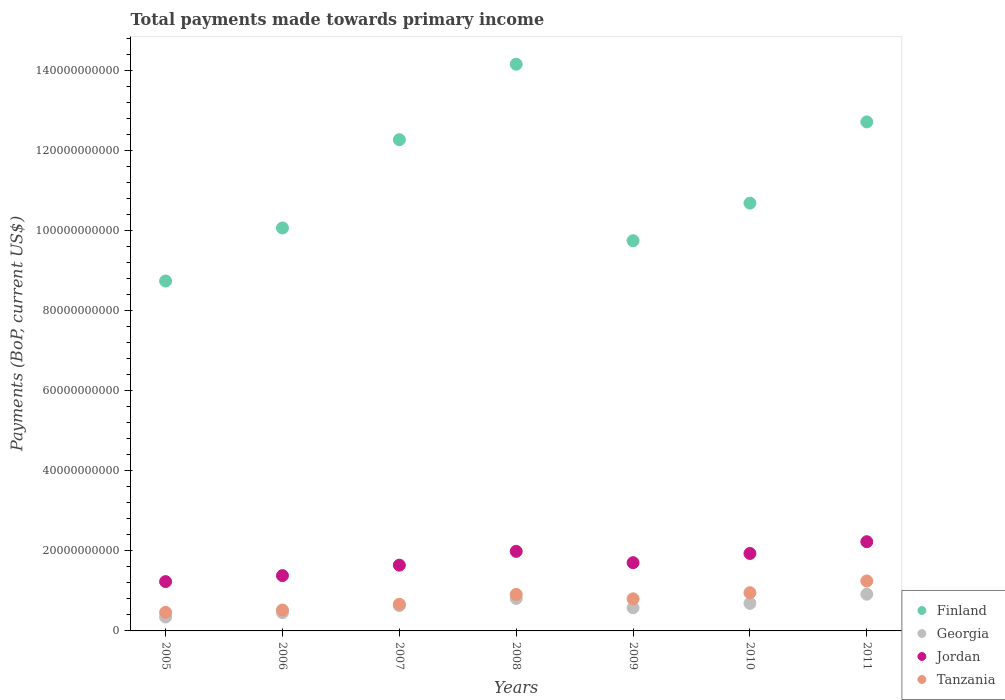Is the number of dotlines equal to the number of legend labels?
Your response must be concise. Yes. What is the total payments made towards primary income in Tanzania in 2008?
Provide a short and direct response. 9.11e+09. Across all years, what is the maximum total payments made towards primary income in Finland?
Provide a short and direct response. 1.42e+11. Across all years, what is the minimum total payments made towards primary income in Tanzania?
Your answer should be compact. 4.64e+09. In which year was the total payments made towards primary income in Georgia maximum?
Provide a short and direct response. 2011. In which year was the total payments made towards primary income in Finland minimum?
Ensure brevity in your answer.  2005. What is the total total payments made towards primary income in Jordan in the graph?
Keep it short and to the point. 1.21e+11. What is the difference between the total payments made towards primary income in Jordan in 2009 and that in 2011?
Ensure brevity in your answer.  -5.23e+09. What is the difference between the total payments made towards primary income in Tanzania in 2006 and the total payments made towards primary income in Finland in 2009?
Offer a terse response. -9.22e+1. What is the average total payments made towards primary income in Jordan per year?
Your response must be concise. 1.73e+1. In the year 2005, what is the difference between the total payments made towards primary income in Finland and total payments made towards primary income in Jordan?
Your answer should be compact. 7.51e+1. In how many years, is the total payments made towards primary income in Jordan greater than 96000000000 US$?
Your answer should be compact. 0. What is the ratio of the total payments made towards primary income in Finland in 2006 to that in 2009?
Offer a very short reply. 1.03. Is the difference between the total payments made towards primary income in Finland in 2005 and 2010 greater than the difference between the total payments made towards primary income in Jordan in 2005 and 2010?
Give a very brief answer. No. What is the difference between the highest and the second highest total payments made towards primary income in Jordan?
Your response must be concise. 2.41e+09. What is the difference between the highest and the lowest total payments made towards primary income in Jordan?
Offer a terse response. 9.96e+09. In how many years, is the total payments made towards primary income in Finland greater than the average total payments made towards primary income in Finland taken over all years?
Make the answer very short. 3. Is the sum of the total payments made towards primary income in Tanzania in 2008 and 2010 greater than the maximum total payments made towards primary income in Georgia across all years?
Make the answer very short. Yes. Is it the case that in every year, the sum of the total payments made towards primary income in Tanzania and total payments made towards primary income in Finland  is greater than the sum of total payments made towards primary income in Georgia and total payments made towards primary income in Jordan?
Your answer should be very brief. Yes. Is it the case that in every year, the sum of the total payments made towards primary income in Georgia and total payments made towards primary income in Tanzania  is greater than the total payments made towards primary income in Jordan?
Your answer should be compact. No. How many dotlines are there?
Ensure brevity in your answer.  4. What is the difference between two consecutive major ticks on the Y-axis?
Your response must be concise. 2.00e+1. Are the values on the major ticks of Y-axis written in scientific E-notation?
Provide a short and direct response. No. Does the graph contain grids?
Keep it short and to the point. No. Where does the legend appear in the graph?
Your response must be concise. Bottom right. What is the title of the graph?
Ensure brevity in your answer.  Total payments made towards primary income. Does "Costa Rica" appear as one of the legend labels in the graph?
Keep it short and to the point. No. What is the label or title of the Y-axis?
Give a very brief answer. Payments (BoP, current US$). What is the Payments (BoP, current US$) of Finland in 2005?
Your response must be concise. 8.74e+1. What is the Payments (BoP, current US$) in Georgia in 2005?
Give a very brief answer. 3.47e+09. What is the Payments (BoP, current US$) of Jordan in 2005?
Ensure brevity in your answer.  1.23e+1. What is the Payments (BoP, current US$) of Tanzania in 2005?
Give a very brief answer. 4.64e+09. What is the Payments (BoP, current US$) of Finland in 2006?
Your answer should be very brief. 1.01e+11. What is the Payments (BoP, current US$) in Georgia in 2006?
Provide a succinct answer. 4.56e+09. What is the Payments (BoP, current US$) in Jordan in 2006?
Provide a succinct answer. 1.38e+1. What is the Payments (BoP, current US$) in Tanzania in 2006?
Offer a terse response. 5.22e+09. What is the Payments (BoP, current US$) in Finland in 2007?
Provide a succinct answer. 1.23e+11. What is the Payments (BoP, current US$) in Georgia in 2007?
Your answer should be very brief. 6.32e+09. What is the Payments (BoP, current US$) in Jordan in 2007?
Make the answer very short. 1.64e+1. What is the Payments (BoP, current US$) in Tanzania in 2007?
Make the answer very short. 6.66e+09. What is the Payments (BoP, current US$) of Finland in 2008?
Your answer should be very brief. 1.42e+11. What is the Payments (BoP, current US$) of Georgia in 2008?
Offer a terse response. 8.11e+09. What is the Payments (BoP, current US$) of Jordan in 2008?
Keep it short and to the point. 1.99e+1. What is the Payments (BoP, current US$) in Tanzania in 2008?
Your response must be concise. 9.11e+09. What is the Payments (BoP, current US$) of Finland in 2009?
Offer a very short reply. 9.74e+1. What is the Payments (BoP, current US$) of Georgia in 2009?
Offer a terse response. 5.78e+09. What is the Payments (BoP, current US$) in Jordan in 2009?
Ensure brevity in your answer.  1.70e+1. What is the Payments (BoP, current US$) in Tanzania in 2009?
Provide a succinct answer. 8.02e+09. What is the Payments (BoP, current US$) in Finland in 2010?
Give a very brief answer. 1.07e+11. What is the Payments (BoP, current US$) of Georgia in 2010?
Make the answer very short. 6.89e+09. What is the Payments (BoP, current US$) in Jordan in 2010?
Keep it short and to the point. 1.93e+1. What is the Payments (BoP, current US$) of Tanzania in 2010?
Offer a very short reply. 9.54e+09. What is the Payments (BoP, current US$) of Finland in 2011?
Provide a succinct answer. 1.27e+11. What is the Payments (BoP, current US$) of Georgia in 2011?
Keep it short and to the point. 9.17e+09. What is the Payments (BoP, current US$) in Jordan in 2011?
Keep it short and to the point. 2.23e+1. What is the Payments (BoP, current US$) of Tanzania in 2011?
Keep it short and to the point. 1.25e+1. Across all years, what is the maximum Payments (BoP, current US$) of Finland?
Make the answer very short. 1.42e+11. Across all years, what is the maximum Payments (BoP, current US$) of Georgia?
Give a very brief answer. 9.17e+09. Across all years, what is the maximum Payments (BoP, current US$) in Jordan?
Give a very brief answer. 2.23e+1. Across all years, what is the maximum Payments (BoP, current US$) of Tanzania?
Offer a terse response. 1.25e+1. Across all years, what is the minimum Payments (BoP, current US$) in Finland?
Provide a short and direct response. 8.74e+1. Across all years, what is the minimum Payments (BoP, current US$) in Georgia?
Your answer should be very brief. 3.47e+09. Across all years, what is the minimum Payments (BoP, current US$) in Jordan?
Give a very brief answer. 1.23e+1. Across all years, what is the minimum Payments (BoP, current US$) of Tanzania?
Offer a very short reply. 4.64e+09. What is the total Payments (BoP, current US$) in Finland in the graph?
Keep it short and to the point. 7.84e+11. What is the total Payments (BoP, current US$) in Georgia in the graph?
Keep it short and to the point. 4.43e+1. What is the total Payments (BoP, current US$) of Jordan in the graph?
Make the answer very short. 1.21e+11. What is the total Payments (BoP, current US$) in Tanzania in the graph?
Give a very brief answer. 5.57e+1. What is the difference between the Payments (BoP, current US$) in Finland in 2005 and that in 2006?
Keep it short and to the point. -1.32e+1. What is the difference between the Payments (BoP, current US$) of Georgia in 2005 and that in 2006?
Your response must be concise. -1.09e+09. What is the difference between the Payments (BoP, current US$) of Jordan in 2005 and that in 2006?
Your answer should be compact. -1.50e+09. What is the difference between the Payments (BoP, current US$) of Tanzania in 2005 and that in 2006?
Provide a succinct answer. -5.76e+08. What is the difference between the Payments (BoP, current US$) in Finland in 2005 and that in 2007?
Your answer should be very brief. -3.53e+1. What is the difference between the Payments (BoP, current US$) in Georgia in 2005 and that in 2007?
Offer a very short reply. -2.86e+09. What is the difference between the Payments (BoP, current US$) of Jordan in 2005 and that in 2007?
Keep it short and to the point. -4.11e+09. What is the difference between the Payments (BoP, current US$) in Tanzania in 2005 and that in 2007?
Offer a terse response. -2.02e+09. What is the difference between the Payments (BoP, current US$) of Finland in 2005 and that in 2008?
Keep it short and to the point. -5.41e+1. What is the difference between the Payments (BoP, current US$) of Georgia in 2005 and that in 2008?
Give a very brief answer. -4.65e+09. What is the difference between the Payments (BoP, current US$) in Jordan in 2005 and that in 2008?
Ensure brevity in your answer.  -7.55e+09. What is the difference between the Payments (BoP, current US$) of Tanzania in 2005 and that in 2008?
Offer a very short reply. -4.47e+09. What is the difference between the Payments (BoP, current US$) in Finland in 2005 and that in 2009?
Your answer should be very brief. -1.01e+1. What is the difference between the Payments (BoP, current US$) of Georgia in 2005 and that in 2009?
Your answer should be very brief. -2.31e+09. What is the difference between the Payments (BoP, current US$) in Jordan in 2005 and that in 2009?
Offer a terse response. -4.73e+09. What is the difference between the Payments (BoP, current US$) of Tanzania in 2005 and that in 2009?
Ensure brevity in your answer.  -3.37e+09. What is the difference between the Payments (BoP, current US$) in Finland in 2005 and that in 2010?
Provide a short and direct response. -1.94e+1. What is the difference between the Payments (BoP, current US$) of Georgia in 2005 and that in 2010?
Provide a short and direct response. -3.42e+09. What is the difference between the Payments (BoP, current US$) in Jordan in 2005 and that in 2010?
Provide a succinct answer. -7.03e+09. What is the difference between the Payments (BoP, current US$) in Tanzania in 2005 and that in 2010?
Your response must be concise. -4.90e+09. What is the difference between the Payments (BoP, current US$) of Finland in 2005 and that in 2011?
Make the answer very short. -3.97e+1. What is the difference between the Payments (BoP, current US$) in Georgia in 2005 and that in 2011?
Make the answer very short. -5.70e+09. What is the difference between the Payments (BoP, current US$) of Jordan in 2005 and that in 2011?
Provide a succinct answer. -9.96e+09. What is the difference between the Payments (BoP, current US$) of Tanzania in 2005 and that in 2011?
Your answer should be very brief. -7.84e+09. What is the difference between the Payments (BoP, current US$) of Finland in 2006 and that in 2007?
Your response must be concise. -2.20e+1. What is the difference between the Payments (BoP, current US$) in Georgia in 2006 and that in 2007?
Provide a succinct answer. -1.77e+09. What is the difference between the Payments (BoP, current US$) of Jordan in 2006 and that in 2007?
Offer a terse response. -2.61e+09. What is the difference between the Payments (BoP, current US$) of Tanzania in 2006 and that in 2007?
Provide a succinct answer. -1.45e+09. What is the difference between the Payments (BoP, current US$) in Finland in 2006 and that in 2008?
Offer a terse response. -4.09e+1. What is the difference between the Payments (BoP, current US$) in Georgia in 2006 and that in 2008?
Give a very brief answer. -3.56e+09. What is the difference between the Payments (BoP, current US$) of Jordan in 2006 and that in 2008?
Provide a short and direct response. -6.06e+09. What is the difference between the Payments (BoP, current US$) of Tanzania in 2006 and that in 2008?
Ensure brevity in your answer.  -3.89e+09. What is the difference between the Payments (BoP, current US$) in Finland in 2006 and that in 2009?
Make the answer very short. 3.19e+09. What is the difference between the Payments (BoP, current US$) of Georgia in 2006 and that in 2009?
Your response must be concise. -1.22e+09. What is the difference between the Payments (BoP, current US$) in Jordan in 2006 and that in 2009?
Give a very brief answer. -3.23e+09. What is the difference between the Payments (BoP, current US$) of Tanzania in 2006 and that in 2009?
Provide a short and direct response. -2.80e+09. What is the difference between the Payments (BoP, current US$) in Finland in 2006 and that in 2010?
Your response must be concise. -6.19e+09. What is the difference between the Payments (BoP, current US$) in Georgia in 2006 and that in 2010?
Offer a very short reply. -2.33e+09. What is the difference between the Payments (BoP, current US$) of Jordan in 2006 and that in 2010?
Offer a very short reply. -5.53e+09. What is the difference between the Payments (BoP, current US$) in Tanzania in 2006 and that in 2010?
Your answer should be compact. -4.32e+09. What is the difference between the Payments (BoP, current US$) of Finland in 2006 and that in 2011?
Offer a terse response. -2.65e+1. What is the difference between the Payments (BoP, current US$) in Georgia in 2006 and that in 2011?
Keep it short and to the point. -4.61e+09. What is the difference between the Payments (BoP, current US$) of Jordan in 2006 and that in 2011?
Ensure brevity in your answer.  -8.47e+09. What is the difference between the Payments (BoP, current US$) in Tanzania in 2006 and that in 2011?
Ensure brevity in your answer.  -7.26e+09. What is the difference between the Payments (BoP, current US$) in Finland in 2007 and that in 2008?
Your answer should be very brief. -1.89e+1. What is the difference between the Payments (BoP, current US$) of Georgia in 2007 and that in 2008?
Offer a very short reply. -1.79e+09. What is the difference between the Payments (BoP, current US$) in Jordan in 2007 and that in 2008?
Provide a succinct answer. -3.45e+09. What is the difference between the Payments (BoP, current US$) in Tanzania in 2007 and that in 2008?
Ensure brevity in your answer.  -2.45e+09. What is the difference between the Payments (BoP, current US$) of Finland in 2007 and that in 2009?
Your answer should be compact. 2.52e+1. What is the difference between the Payments (BoP, current US$) in Georgia in 2007 and that in 2009?
Ensure brevity in your answer.  5.46e+08. What is the difference between the Payments (BoP, current US$) of Jordan in 2007 and that in 2009?
Ensure brevity in your answer.  -6.23e+08. What is the difference between the Payments (BoP, current US$) in Tanzania in 2007 and that in 2009?
Give a very brief answer. -1.35e+09. What is the difference between the Payments (BoP, current US$) in Finland in 2007 and that in 2010?
Your response must be concise. 1.58e+1. What is the difference between the Payments (BoP, current US$) of Georgia in 2007 and that in 2010?
Your answer should be very brief. -5.60e+08. What is the difference between the Payments (BoP, current US$) of Jordan in 2007 and that in 2010?
Keep it short and to the point. -2.92e+09. What is the difference between the Payments (BoP, current US$) of Tanzania in 2007 and that in 2010?
Make the answer very short. -2.88e+09. What is the difference between the Payments (BoP, current US$) of Finland in 2007 and that in 2011?
Keep it short and to the point. -4.45e+09. What is the difference between the Payments (BoP, current US$) in Georgia in 2007 and that in 2011?
Provide a succinct answer. -2.84e+09. What is the difference between the Payments (BoP, current US$) in Jordan in 2007 and that in 2011?
Offer a very short reply. -5.86e+09. What is the difference between the Payments (BoP, current US$) in Tanzania in 2007 and that in 2011?
Ensure brevity in your answer.  -5.81e+09. What is the difference between the Payments (BoP, current US$) of Finland in 2008 and that in 2009?
Keep it short and to the point. 4.41e+1. What is the difference between the Payments (BoP, current US$) in Georgia in 2008 and that in 2009?
Ensure brevity in your answer.  2.34e+09. What is the difference between the Payments (BoP, current US$) of Jordan in 2008 and that in 2009?
Provide a succinct answer. 2.82e+09. What is the difference between the Payments (BoP, current US$) of Tanzania in 2008 and that in 2009?
Your response must be concise. 1.10e+09. What is the difference between the Payments (BoP, current US$) of Finland in 2008 and that in 2010?
Provide a short and direct response. 3.47e+1. What is the difference between the Payments (BoP, current US$) of Georgia in 2008 and that in 2010?
Your answer should be very brief. 1.23e+09. What is the difference between the Payments (BoP, current US$) of Jordan in 2008 and that in 2010?
Offer a terse response. 5.25e+08. What is the difference between the Payments (BoP, current US$) of Tanzania in 2008 and that in 2010?
Your answer should be compact. -4.30e+08. What is the difference between the Payments (BoP, current US$) in Finland in 2008 and that in 2011?
Offer a very short reply. 1.44e+1. What is the difference between the Payments (BoP, current US$) of Georgia in 2008 and that in 2011?
Ensure brevity in your answer.  -1.05e+09. What is the difference between the Payments (BoP, current US$) in Jordan in 2008 and that in 2011?
Make the answer very short. -2.41e+09. What is the difference between the Payments (BoP, current US$) of Tanzania in 2008 and that in 2011?
Offer a terse response. -3.37e+09. What is the difference between the Payments (BoP, current US$) of Finland in 2009 and that in 2010?
Keep it short and to the point. -9.38e+09. What is the difference between the Payments (BoP, current US$) in Georgia in 2009 and that in 2010?
Offer a terse response. -1.11e+09. What is the difference between the Payments (BoP, current US$) of Jordan in 2009 and that in 2010?
Make the answer very short. -2.30e+09. What is the difference between the Payments (BoP, current US$) in Tanzania in 2009 and that in 2010?
Your answer should be very brief. -1.53e+09. What is the difference between the Payments (BoP, current US$) in Finland in 2009 and that in 2011?
Your answer should be very brief. -2.97e+1. What is the difference between the Payments (BoP, current US$) of Georgia in 2009 and that in 2011?
Make the answer very short. -3.39e+09. What is the difference between the Payments (BoP, current US$) in Jordan in 2009 and that in 2011?
Offer a very short reply. -5.23e+09. What is the difference between the Payments (BoP, current US$) in Tanzania in 2009 and that in 2011?
Provide a succinct answer. -4.46e+09. What is the difference between the Payments (BoP, current US$) in Finland in 2010 and that in 2011?
Ensure brevity in your answer.  -2.03e+1. What is the difference between the Payments (BoP, current US$) of Georgia in 2010 and that in 2011?
Keep it short and to the point. -2.28e+09. What is the difference between the Payments (BoP, current US$) of Jordan in 2010 and that in 2011?
Your answer should be compact. -2.93e+09. What is the difference between the Payments (BoP, current US$) of Tanzania in 2010 and that in 2011?
Keep it short and to the point. -2.94e+09. What is the difference between the Payments (BoP, current US$) in Finland in 2005 and the Payments (BoP, current US$) in Georgia in 2006?
Provide a short and direct response. 8.28e+1. What is the difference between the Payments (BoP, current US$) of Finland in 2005 and the Payments (BoP, current US$) of Jordan in 2006?
Provide a succinct answer. 7.36e+1. What is the difference between the Payments (BoP, current US$) of Finland in 2005 and the Payments (BoP, current US$) of Tanzania in 2006?
Make the answer very short. 8.22e+1. What is the difference between the Payments (BoP, current US$) in Georgia in 2005 and the Payments (BoP, current US$) in Jordan in 2006?
Provide a succinct answer. -1.03e+1. What is the difference between the Payments (BoP, current US$) in Georgia in 2005 and the Payments (BoP, current US$) in Tanzania in 2006?
Your answer should be very brief. -1.75e+09. What is the difference between the Payments (BoP, current US$) of Jordan in 2005 and the Payments (BoP, current US$) of Tanzania in 2006?
Offer a very short reply. 7.10e+09. What is the difference between the Payments (BoP, current US$) in Finland in 2005 and the Payments (BoP, current US$) in Georgia in 2007?
Keep it short and to the point. 8.11e+1. What is the difference between the Payments (BoP, current US$) of Finland in 2005 and the Payments (BoP, current US$) of Jordan in 2007?
Provide a short and direct response. 7.10e+1. What is the difference between the Payments (BoP, current US$) in Finland in 2005 and the Payments (BoP, current US$) in Tanzania in 2007?
Your answer should be compact. 8.07e+1. What is the difference between the Payments (BoP, current US$) in Georgia in 2005 and the Payments (BoP, current US$) in Jordan in 2007?
Keep it short and to the point. -1.30e+1. What is the difference between the Payments (BoP, current US$) of Georgia in 2005 and the Payments (BoP, current US$) of Tanzania in 2007?
Keep it short and to the point. -3.19e+09. What is the difference between the Payments (BoP, current US$) in Jordan in 2005 and the Payments (BoP, current US$) in Tanzania in 2007?
Provide a succinct answer. 5.65e+09. What is the difference between the Payments (BoP, current US$) of Finland in 2005 and the Payments (BoP, current US$) of Georgia in 2008?
Provide a short and direct response. 7.93e+1. What is the difference between the Payments (BoP, current US$) of Finland in 2005 and the Payments (BoP, current US$) of Jordan in 2008?
Ensure brevity in your answer.  6.75e+1. What is the difference between the Payments (BoP, current US$) in Finland in 2005 and the Payments (BoP, current US$) in Tanzania in 2008?
Offer a very short reply. 7.83e+1. What is the difference between the Payments (BoP, current US$) in Georgia in 2005 and the Payments (BoP, current US$) in Jordan in 2008?
Offer a very short reply. -1.64e+1. What is the difference between the Payments (BoP, current US$) of Georgia in 2005 and the Payments (BoP, current US$) of Tanzania in 2008?
Your answer should be compact. -5.64e+09. What is the difference between the Payments (BoP, current US$) in Jordan in 2005 and the Payments (BoP, current US$) in Tanzania in 2008?
Make the answer very short. 3.20e+09. What is the difference between the Payments (BoP, current US$) of Finland in 2005 and the Payments (BoP, current US$) of Georgia in 2009?
Keep it short and to the point. 8.16e+1. What is the difference between the Payments (BoP, current US$) in Finland in 2005 and the Payments (BoP, current US$) in Jordan in 2009?
Your answer should be very brief. 7.03e+1. What is the difference between the Payments (BoP, current US$) of Finland in 2005 and the Payments (BoP, current US$) of Tanzania in 2009?
Provide a short and direct response. 7.94e+1. What is the difference between the Payments (BoP, current US$) in Georgia in 2005 and the Payments (BoP, current US$) in Jordan in 2009?
Keep it short and to the point. -1.36e+1. What is the difference between the Payments (BoP, current US$) of Georgia in 2005 and the Payments (BoP, current US$) of Tanzania in 2009?
Provide a short and direct response. -4.55e+09. What is the difference between the Payments (BoP, current US$) of Jordan in 2005 and the Payments (BoP, current US$) of Tanzania in 2009?
Your response must be concise. 4.30e+09. What is the difference between the Payments (BoP, current US$) in Finland in 2005 and the Payments (BoP, current US$) in Georgia in 2010?
Your answer should be very brief. 8.05e+1. What is the difference between the Payments (BoP, current US$) in Finland in 2005 and the Payments (BoP, current US$) in Jordan in 2010?
Keep it short and to the point. 6.80e+1. What is the difference between the Payments (BoP, current US$) in Finland in 2005 and the Payments (BoP, current US$) in Tanzania in 2010?
Your answer should be very brief. 7.78e+1. What is the difference between the Payments (BoP, current US$) of Georgia in 2005 and the Payments (BoP, current US$) of Jordan in 2010?
Your response must be concise. -1.59e+1. What is the difference between the Payments (BoP, current US$) of Georgia in 2005 and the Payments (BoP, current US$) of Tanzania in 2010?
Offer a terse response. -6.07e+09. What is the difference between the Payments (BoP, current US$) of Jordan in 2005 and the Payments (BoP, current US$) of Tanzania in 2010?
Give a very brief answer. 2.77e+09. What is the difference between the Payments (BoP, current US$) of Finland in 2005 and the Payments (BoP, current US$) of Georgia in 2011?
Offer a terse response. 7.82e+1. What is the difference between the Payments (BoP, current US$) of Finland in 2005 and the Payments (BoP, current US$) of Jordan in 2011?
Provide a short and direct response. 6.51e+1. What is the difference between the Payments (BoP, current US$) of Finland in 2005 and the Payments (BoP, current US$) of Tanzania in 2011?
Your answer should be very brief. 7.49e+1. What is the difference between the Payments (BoP, current US$) of Georgia in 2005 and the Payments (BoP, current US$) of Jordan in 2011?
Ensure brevity in your answer.  -1.88e+1. What is the difference between the Payments (BoP, current US$) in Georgia in 2005 and the Payments (BoP, current US$) in Tanzania in 2011?
Make the answer very short. -9.01e+09. What is the difference between the Payments (BoP, current US$) of Jordan in 2005 and the Payments (BoP, current US$) of Tanzania in 2011?
Keep it short and to the point. -1.63e+08. What is the difference between the Payments (BoP, current US$) in Finland in 2006 and the Payments (BoP, current US$) in Georgia in 2007?
Your response must be concise. 9.43e+1. What is the difference between the Payments (BoP, current US$) of Finland in 2006 and the Payments (BoP, current US$) of Jordan in 2007?
Give a very brief answer. 8.42e+1. What is the difference between the Payments (BoP, current US$) in Finland in 2006 and the Payments (BoP, current US$) in Tanzania in 2007?
Offer a very short reply. 9.40e+1. What is the difference between the Payments (BoP, current US$) of Georgia in 2006 and the Payments (BoP, current US$) of Jordan in 2007?
Offer a terse response. -1.19e+1. What is the difference between the Payments (BoP, current US$) in Georgia in 2006 and the Payments (BoP, current US$) in Tanzania in 2007?
Give a very brief answer. -2.11e+09. What is the difference between the Payments (BoP, current US$) of Jordan in 2006 and the Payments (BoP, current US$) of Tanzania in 2007?
Offer a terse response. 7.15e+09. What is the difference between the Payments (BoP, current US$) in Finland in 2006 and the Payments (BoP, current US$) in Georgia in 2008?
Your answer should be very brief. 9.25e+1. What is the difference between the Payments (BoP, current US$) in Finland in 2006 and the Payments (BoP, current US$) in Jordan in 2008?
Provide a succinct answer. 8.08e+1. What is the difference between the Payments (BoP, current US$) in Finland in 2006 and the Payments (BoP, current US$) in Tanzania in 2008?
Give a very brief answer. 9.15e+1. What is the difference between the Payments (BoP, current US$) in Georgia in 2006 and the Payments (BoP, current US$) in Jordan in 2008?
Offer a very short reply. -1.53e+1. What is the difference between the Payments (BoP, current US$) of Georgia in 2006 and the Payments (BoP, current US$) of Tanzania in 2008?
Your answer should be very brief. -4.56e+09. What is the difference between the Payments (BoP, current US$) in Jordan in 2006 and the Payments (BoP, current US$) in Tanzania in 2008?
Give a very brief answer. 4.70e+09. What is the difference between the Payments (BoP, current US$) in Finland in 2006 and the Payments (BoP, current US$) in Georgia in 2009?
Your answer should be very brief. 9.49e+1. What is the difference between the Payments (BoP, current US$) in Finland in 2006 and the Payments (BoP, current US$) in Jordan in 2009?
Ensure brevity in your answer.  8.36e+1. What is the difference between the Payments (BoP, current US$) of Finland in 2006 and the Payments (BoP, current US$) of Tanzania in 2009?
Provide a short and direct response. 9.26e+1. What is the difference between the Payments (BoP, current US$) of Georgia in 2006 and the Payments (BoP, current US$) of Jordan in 2009?
Provide a succinct answer. -1.25e+1. What is the difference between the Payments (BoP, current US$) in Georgia in 2006 and the Payments (BoP, current US$) in Tanzania in 2009?
Your answer should be very brief. -3.46e+09. What is the difference between the Payments (BoP, current US$) of Jordan in 2006 and the Payments (BoP, current US$) of Tanzania in 2009?
Offer a terse response. 5.79e+09. What is the difference between the Payments (BoP, current US$) in Finland in 2006 and the Payments (BoP, current US$) in Georgia in 2010?
Give a very brief answer. 9.37e+1. What is the difference between the Payments (BoP, current US$) of Finland in 2006 and the Payments (BoP, current US$) of Jordan in 2010?
Your answer should be very brief. 8.13e+1. What is the difference between the Payments (BoP, current US$) of Finland in 2006 and the Payments (BoP, current US$) of Tanzania in 2010?
Give a very brief answer. 9.11e+1. What is the difference between the Payments (BoP, current US$) in Georgia in 2006 and the Payments (BoP, current US$) in Jordan in 2010?
Give a very brief answer. -1.48e+1. What is the difference between the Payments (BoP, current US$) in Georgia in 2006 and the Payments (BoP, current US$) in Tanzania in 2010?
Provide a short and direct response. -4.99e+09. What is the difference between the Payments (BoP, current US$) of Jordan in 2006 and the Payments (BoP, current US$) of Tanzania in 2010?
Provide a succinct answer. 4.27e+09. What is the difference between the Payments (BoP, current US$) of Finland in 2006 and the Payments (BoP, current US$) of Georgia in 2011?
Your response must be concise. 9.15e+1. What is the difference between the Payments (BoP, current US$) of Finland in 2006 and the Payments (BoP, current US$) of Jordan in 2011?
Your answer should be compact. 7.84e+1. What is the difference between the Payments (BoP, current US$) in Finland in 2006 and the Payments (BoP, current US$) in Tanzania in 2011?
Your answer should be very brief. 8.82e+1. What is the difference between the Payments (BoP, current US$) in Georgia in 2006 and the Payments (BoP, current US$) in Jordan in 2011?
Your answer should be compact. -1.77e+1. What is the difference between the Payments (BoP, current US$) of Georgia in 2006 and the Payments (BoP, current US$) of Tanzania in 2011?
Your answer should be very brief. -7.92e+09. What is the difference between the Payments (BoP, current US$) in Jordan in 2006 and the Payments (BoP, current US$) in Tanzania in 2011?
Ensure brevity in your answer.  1.33e+09. What is the difference between the Payments (BoP, current US$) in Finland in 2007 and the Payments (BoP, current US$) in Georgia in 2008?
Offer a terse response. 1.15e+11. What is the difference between the Payments (BoP, current US$) in Finland in 2007 and the Payments (BoP, current US$) in Jordan in 2008?
Your response must be concise. 1.03e+11. What is the difference between the Payments (BoP, current US$) in Finland in 2007 and the Payments (BoP, current US$) in Tanzania in 2008?
Keep it short and to the point. 1.14e+11. What is the difference between the Payments (BoP, current US$) in Georgia in 2007 and the Payments (BoP, current US$) in Jordan in 2008?
Ensure brevity in your answer.  -1.35e+1. What is the difference between the Payments (BoP, current US$) in Georgia in 2007 and the Payments (BoP, current US$) in Tanzania in 2008?
Your response must be concise. -2.79e+09. What is the difference between the Payments (BoP, current US$) in Jordan in 2007 and the Payments (BoP, current US$) in Tanzania in 2008?
Provide a succinct answer. 7.31e+09. What is the difference between the Payments (BoP, current US$) in Finland in 2007 and the Payments (BoP, current US$) in Georgia in 2009?
Ensure brevity in your answer.  1.17e+11. What is the difference between the Payments (BoP, current US$) in Finland in 2007 and the Payments (BoP, current US$) in Jordan in 2009?
Offer a very short reply. 1.06e+11. What is the difference between the Payments (BoP, current US$) in Finland in 2007 and the Payments (BoP, current US$) in Tanzania in 2009?
Your answer should be very brief. 1.15e+11. What is the difference between the Payments (BoP, current US$) in Georgia in 2007 and the Payments (BoP, current US$) in Jordan in 2009?
Offer a very short reply. -1.07e+1. What is the difference between the Payments (BoP, current US$) of Georgia in 2007 and the Payments (BoP, current US$) of Tanzania in 2009?
Your response must be concise. -1.69e+09. What is the difference between the Payments (BoP, current US$) in Jordan in 2007 and the Payments (BoP, current US$) in Tanzania in 2009?
Offer a very short reply. 8.41e+09. What is the difference between the Payments (BoP, current US$) in Finland in 2007 and the Payments (BoP, current US$) in Georgia in 2010?
Offer a very short reply. 1.16e+11. What is the difference between the Payments (BoP, current US$) in Finland in 2007 and the Payments (BoP, current US$) in Jordan in 2010?
Your response must be concise. 1.03e+11. What is the difference between the Payments (BoP, current US$) of Finland in 2007 and the Payments (BoP, current US$) of Tanzania in 2010?
Your response must be concise. 1.13e+11. What is the difference between the Payments (BoP, current US$) in Georgia in 2007 and the Payments (BoP, current US$) in Jordan in 2010?
Offer a terse response. -1.30e+1. What is the difference between the Payments (BoP, current US$) in Georgia in 2007 and the Payments (BoP, current US$) in Tanzania in 2010?
Offer a very short reply. -3.22e+09. What is the difference between the Payments (BoP, current US$) in Jordan in 2007 and the Payments (BoP, current US$) in Tanzania in 2010?
Your answer should be very brief. 6.88e+09. What is the difference between the Payments (BoP, current US$) in Finland in 2007 and the Payments (BoP, current US$) in Georgia in 2011?
Make the answer very short. 1.14e+11. What is the difference between the Payments (BoP, current US$) in Finland in 2007 and the Payments (BoP, current US$) in Jordan in 2011?
Make the answer very short. 1.00e+11. What is the difference between the Payments (BoP, current US$) of Finland in 2007 and the Payments (BoP, current US$) of Tanzania in 2011?
Provide a short and direct response. 1.10e+11. What is the difference between the Payments (BoP, current US$) in Georgia in 2007 and the Payments (BoP, current US$) in Jordan in 2011?
Ensure brevity in your answer.  -1.60e+1. What is the difference between the Payments (BoP, current US$) of Georgia in 2007 and the Payments (BoP, current US$) of Tanzania in 2011?
Offer a terse response. -6.15e+09. What is the difference between the Payments (BoP, current US$) in Jordan in 2007 and the Payments (BoP, current US$) in Tanzania in 2011?
Make the answer very short. 3.94e+09. What is the difference between the Payments (BoP, current US$) of Finland in 2008 and the Payments (BoP, current US$) of Georgia in 2009?
Offer a terse response. 1.36e+11. What is the difference between the Payments (BoP, current US$) in Finland in 2008 and the Payments (BoP, current US$) in Jordan in 2009?
Your response must be concise. 1.24e+11. What is the difference between the Payments (BoP, current US$) in Finland in 2008 and the Payments (BoP, current US$) in Tanzania in 2009?
Your answer should be very brief. 1.34e+11. What is the difference between the Payments (BoP, current US$) in Georgia in 2008 and the Payments (BoP, current US$) in Jordan in 2009?
Provide a short and direct response. -8.93e+09. What is the difference between the Payments (BoP, current US$) in Georgia in 2008 and the Payments (BoP, current US$) in Tanzania in 2009?
Your answer should be very brief. 9.99e+07. What is the difference between the Payments (BoP, current US$) of Jordan in 2008 and the Payments (BoP, current US$) of Tanzania in 2009?
Offer a terse response. 1.19e+1. What is the difference between the Payments (BoP, current US$) of Finland in 2008 and the Payments (BoP, current US$) of Georgia in 2010?
Your response must be concise. 1.35e+11. What is the difference between the Payments (BoP, current US$) of Finland in 2008 and the Payments (BoP, current US$) of Jordan in 2010?
Ensure brevity in your answer.  1.22e+11. What is the difference between the Payments (BoP, current US$) of Finland in 2008 and the Payments (BoP, current US$) of Tanzania in 2010?
Ensure brevity in your answer.  1.32e+11. What is the difference between the Payments (BoP, current US$) of Georgia in 2008 and the Payments (BoP, current US$) of Jordan in 2010?
Your response must be concise. -1.12e+1. What is the difference between the Payments (BoP, current US$) in Georgia in 2008 and the Payments (BoP, current US$) in Tanzania in 2010?
Offer a very short reply. -1.43e+09. What is the difference between the Payments (BoP, current US$) of Jordan in 2008 and the Payments (BoP, current US$) of Tanzania in 2010?
Ensure brevity in your answer.  1.03e+1. What is the difference between the Payments (BoP, current US$) in Finland in 2008 and the Payments (BoP, current US$) in Georgia in 2011?
Keep it short and to the point. 1.32e+11. What is the difference between the Payments (BoP, current US$) in Finland in 2008 and the Payments (BoP, current US$) in Jordan in 2011?
Give a very brief answer. 1.19e+11. What is the difference between the Payments (BoP, current US$) of Finland in 2008 and the Payments (BoP, current US$) of Tanzania in 2011?
Offer a very short reply. 1.29e+11. What is the difference between the Payments (BoP, current US$) in Georgia in 2008 and the Payments (BoP, current US$) in Jordan in 2011?
Your answer should be compact. -1.42e+1. What is the difference between the Payments (BoP, current US$) of Georgia in 2008 and the Payments (BoP, current US$) of Tanzania in 2011?
Keep it short and to the point. -4.36e+09. What is the difference between the Payments (BoP, current US$) in Jordan in 2008 and the Payments (BoP, current US$) in Tanzania in 2011?
Your answer should be very brief. 7.39e+09. What is the difference between the Payments (BoP, current US$) in Finland in 2009 and the Payments (BoP, current US$) in Georgia in 2010?
Keep it short and to the point. 9.06e+1. What is the difference between the Payments (BoP, current US$) in Finland in 2009 and the Payments (BoP, current US$) in Jordan in 2010?
Make the answer very short. 7.81e+1. What is the difference between the Payments (BoP, current US$) in Finland in 2009 and the Payments (BoP, current US$) in Tanzania in 2010?
Keep it short and to the point. 8.79e+1. What is the difference between the Payments (BoP, current US$) in Georgia in 2009 and the Payments (BoP, current US$) in Jordan in 2010?
Provide a short and direct response. -1.36e+1. What is the difference between the Payments (BoP, current US$) in Georgia in 2009 and the Payments (BoP, current US$) in Tanzania in 2010?
Ensure brevity in your answer.  -3.76e+09. What is the difference between the Payments (BoP, current US$) in Jordan in 2009 and the Payments (BoP, current US$) in Tanzania in 2010?
Your response must be concise. 7.50e+09. What is the difference between the Payments (BoP, current US$) of Finland in 2009 and the Payments (BoP, current US$) of Georgia in 2011?
Offer a very short reply. 8.83e+1. What is the difference between the Payments (BoP, current US$) in Finland in 2009 and the Payments (BoP, current US$) in Jordan in 2011?
Your answer should be compact. 7.52e+1. What is the difference between the Payments (BoP, current US$) of Finland in 2009 and the Payments (BoP, current US$) of Tanzania in 2011?
Make the answer very short. 8.50e+1. What is the difference between the Payments (BoP, current US$) in Georgia in 2009 and the Payments (BoP, current US$) in Jordan in 2011?
Give a very brief answer. -1.65e+1. What is the difference between the Payments (BoP, current US$) of Georgia in 2009 and the Payments (BoP, current US$) of Tanzania in 2011?
Offer a terse response. -6.70e+09. What is the difference between the Payments (BoP, current US$) of Jordan in 2009 and the Payments (BoP, current US$) of Tanzania in 2011?
Provide a short and direct response. 4.57e+09. What is the difference between the Payments (BoP, current US$) in Finland in 2010 and the Payments (BoP, current US$) in Georgia in 2011?
Your response must be concise. 9.77e+1. What is the difference between the Payments (BoP, current US$) in Finland in 2010 and the Payments (BoP, current US$) in Jordan in 2011?
Ensure brevity in your answer.  8.46e+1. What is the difference between the Payments (BoP, current US$) of Finland in 2010 and the Payments (BoP, current US$) of Tanzania in 2011?
Your response must be concise. 9.44e+1. What is the difference between the Payments (BoP, current US$) in Georgia in 2010 and the Payments (BoP, current US$) in Jordan in 2011?
Keep it short and to the point. -1.54e+1. What is the difference between the Payments (BoP, current US$) of Georgia in 2010 and the Payments (BoP, current US$) of Tanzania in 2011?
Offer a terse response. -5.59e+09. What is the difference between the Payments (BoP, current US$) in Jordan in 2010 and the Payments (BoP, current US$) in Tanzania in 2011?
Make the answer very short. 6.87e+09. What is the average Payments (BoP, current US$) of Finland per year?
Ensure brevity in your answer.  1.12e+11. What is the average Payments (BoP, current US$) of Georgia per year?
Give a very brief answer. 6.33e+09. What is the average Payments (BoP, current US$) of Jordan per year?
Provide a succinct answer. 1.73e+1. What is the average Payments (BoP, current US$) in Tanzania per year?
Offer a very short reply. 7.95e+09. In the year 2005, what is the difference between the Payments (BoP, current US$) in Finland and Payments (BoP, current US$) in Georgia?
Offer a terse response. 8.39e+1. In the year 2005, what is the difference between the Payments (BoP, current US$) in Finland and Payments (BoP, current US$) in Jordan?
Offer a terse response. 7.51e+1. In the year 2005, what is the difference between the Payments (BoP, current US$) of Finland and Payments (BoP, current US$) of Tanzania?
Your answer should be compact. 8.27e+1. In the year 2005, what is the difference between the Payments (BoP, current US$) in Georgia and Payments (BoP, current US$) in Jordan?
Your answer should be very brief. -8.84e+09. In the year 2005, what is the difference between the Payments (BoP, current US$) of Georgia and Payments (BoP, current US$) of Tanzania?
Offer a very short reply. -1.17e+09. In the year 2005, what is the difference between the Payments (BoP, current US$) of Jordan and Payments (BoP, current US$) of Tanzania?
Keep it short and to the point. 7.67e+09. In the year 2006, what is the difference between the Payments (BoP, current US$) in Finland and Payments (BoP, current US$) in Georgia?
Offer a terse response. 9.61e+1. In the year 2006, what is the difference between the Payments (BoP, current US$) in Finland and Payments (BoP, current US$) in Jordan?
Keep it short and to the point. 8.68e+1. In the year 2006, what is the difference between the Payments (BoP, current US$) of Finland and Payments (BoP, current US$) of Tanzania?
Offer a very short reply. 9.54e+1. In the year 2006, what is the difference between the Payments (BoP, current US$) of Georgia and Payments (BoP, current US$) of Jordan?
Offer a terse response. -9.25e+09. In the year 2006, what is the difference between the Payments (BoP, current US$) of Georgia and Payments (BoP, current US$) of Tanzania?
Your answer should be compact. -6.61e+08. In the year 2006, what is the difference between the Payments (BoP, current US$) in Jordan and Payments (BoP, current US$) in Tanzania?
Keep it short and to the point. 8.59e+09. In the year 2007, what is the difference between the Payments (BoP, current US$) of Finland and Payments (BoP, current US$) of Georgia?
Make the answer very short. 1.16e+11. In the year 2007, what is the difference between the Payments (BoP, current US$) of Finland and Payments (BoP, current US$) of Jordan?
Offer a terse response. 1.06e+11. In the year 2007, what is the difference between the Payments (BoP, current US$) in Finland and Payments (BoP, current US$) in Tanzania?
Offer a terse response. 1.16e+11. In the year 2007, what is the difference between the Payments (BoP, current US$) in Georgia and Payments (BoP, current US$) in Jordan?
Make the answer very short. -1.01e+1. In the year 2007, what is the difference between the Payments (BoP, current US$) of Georgia and Payments (BoP, current US$) of Tanzania?
Your answer should be compact. -3.39e+08. In the year 2007, what is the difference between the Payments (BoP, current US$) of Jordan and Payments (BoP, current US$) of Tanzania?
Provide a succinct answer. 9.76e+09. In the year 2008, what is the difference between the Payments (BoP, current US$) in Finland and Payments (BoP, current US$) in Georgia?
Keep it short and to the point. 1.33e+11. In the year 2008, what is the difference between the Payments (BoP, current US$) in Finland and Payments (BoP, current US$) in Jordan?
Give a very brief answer. 1.22e+11. In the year 2008, what is the difference between the Payments (BoP, current US$) of Finland and Payments (BoP, current US$) of Tanzania?
Give a very brief answer. 1.32e+11. In the year 2008, what is the difference between the Payments (BoP, current US$) of Georgia and Payments (BoP, current US$) of Jordan?
Make the answer very short. -1.18e+1. In the year 2008, what is the difference between the Payments (BoP, current US$) of Georgia and Payments (BoP, current US$) of Tanzania?
Provide a succinct answer. -9.96e+08. In the year 2008, what is the difference between the Payments (BoP, current US$) in Jordan and Payments (BoP, current US$) in Tanzania?
Your answer should be very brief. 1.08e+1. In the year 2009, what is the difference between the Payments (BoP, current US$) in Finland and Payments (BoP, current US$) in Georgia?
Offer a terse response. 9.17e+1. In the year 2009, what is the difference between the Payments (BoP, current US$) in Finland and Payments (BoP, current US$) in Jordan?
Provide a succinct answer. 8.04e+1. In the year 2009, what is the difference between the Payments (BoP, current US$) in Finland and Payments (BoP, current US$) in Tanzania?
Provide a succinct answer. 8.94e+1. In the year 2009, what is the difference between the Payments (BoP, current US$) of Georgia and Payments (BoP, current US$) of Jordan?
Offer a very short reply. -1.13e+1. In the year 2009, what is the difference between the Payments (BoP, current US$) of Georgia and Payments (BoP, current US$) of Tanzania?
Give a very brief answer. -2.24e+09. In the year 2009, what is the difference between the Payments (BoP, current US$) in Jordan and Payments (BoP, current US$) in Tanzania?
Ensure brevity in your answer.  9.03e+09. In the year 2010, what is the difference between the Payments (BoP, current US$) in Finland and Payments (BoP, current US$) in Georgia?
Make the answer very short. 9.99e+1. In the year 2010, what is the difference between the Payments (BoP, current US$) of Finland and Payments (BoP, current US$) of Jordan?
Keep it short and to the point. 8.75e+1. In the year 2010, what is the difference between the Payments (BoP, current US$) of Finland and Payments (BoP, current US$) of Tanzania?
Offer a terse response. 9.73e+1. In the year 2010, what is the difference between the Payments (BoP, current US$) in Georgia and Payments (BoP, current US$) in Jordan?
Your response must be concise. -1.25e+1. In the year 2010, what is the difference between the Payments (BoP, current US$) of Georgia and Payments (BoP, current US$) of Tanzania?
Keep it short and to the point. -2.66e+09. In the year 2010, what is the difference between the Payments (BoP, current US$) in Jordan and Payments (BoP, current US$) in Tanzania?
Offer a terse response. 9.80e+09. In the year 2011, what is the difference between the Payments (BoP, current US$) of Finland and Payments (BoP, current US$) of Georgia?
Provide a succinct answer. 1.18e+11. In the year 2011, what is the difference between the Payments (BoP, current US$) of Finland and Payments (BoP, current US$) of Jordan?
Offer a very short reply. 1.05e+11. In the year 2011, what is the difference between the Payments (BoP, current US$) of Finland and Payments (BoP, current US$) of Tanzania?
Your response must be concise. 1.15e+11. In the year 2011, what is the difference between the Payments (BoP, current US$) of Georgia and Payments (BoP, current US$) of Jordan?
Keep it short and to the point. -1.31e+1. In the year 2011, what is the difference between the Payments (BoP, current US$) of Georgia and Payments (BoP, current US$) of Tanzania?
Your response must be concise. -3.31e+09. In the year 2011, what is the difference between the Payments (BoP, current US$) in Jordan and Payments (BoP, current US$) in Tanzania?
Keep it short and to the point. 9.80e+09. What is the ratio of the Payments (BoP, current US$) in Finland in 2005 to that in 2006?
Offer a very short reply. 0.87. What is the ratio of the Payments (BoP, current US$) of Georgia in 2005 to that in 2006?
Offer a terse response. 0.76. What is the ratio of the Payments (BoP, current US$) in Jordan in 2005 to that in 2006?
Your answer should be compact. 0.89. What is the ratio of the Payments (BoP, current US$) in Tanzania in 2005 to that in 2006?
Provide a short and direct response. 0.89. What is the ratio of the Payments (BoP, current US$) in Finland in 2005 to that in 2007?
Your response must be concise. 0.71. What is the ratio of the Payments (BoP, current US$) of Georgia in 2005 to that in 2007?
Your answer should be very brief. 0.55. What is the ratio of the Payments (BoP, current US$) of Jordan in 2005 to that in 2007?
Make the answer very short. 0.75. What is the ratio of the Payments (BoP, current US$) in Tanzania in 2005 to that in 2007?
Your answer should be very brief. 0.7. What is the ratio of the Payments (BoP, current US$) in Finland in 2005 to that in 2008?
Provide a short and direct response. 0.62. What is the ratio of the Payments (BoP, current US$) in Georgia in 2005 to that in 2008?
Keep it short and to the point. 0.43. What is the ratio of the Payments (BoP, current US$) in Jordan in 2005 to that in 2008?
Your answer should be very brief. 0.62. What is the ratio of the Payments (BoP, current US$) in Tanzania in 2005 to that in 2008?
Your response must be concise. 0.51. What is the ratio of the Payments (BoP, current US$) in Finland in 2005 to that in 2009?
Keep it short and to the point. 0.9. What is the ratio of the Payments (BoP, current US$) in Georgia in 2005 to that in 2009?
Offer a terse response. 0.6. What is the ratio of the Payments (BoP, current US$) in Jordan in 2005 to that in 2009?
Provide a succinct answer. 0.72. What is the ratio of the Payments (BoP, current US$) in Tanzania in 2005 to that in 2009?
Ensure brevity in your answer.  0.58. What is the ratio of the Payments (BoP, current US$) of Finland in 2005 to that in 2010?
Make the answer very short. 0.82. What is the ratio of the Payments (BoP, current US$) in Georgia in 2005 to that in 2010?
Offer a terse response. 0.5. What is the ratio of the Payments (BoP, current US$) in Jordan in 2005 to that in 2010?
Offer a terse response. 0.64. What is the ratio of the Payments (BoP, current US$) of Tanzania in 2005 to that in 2010?
Ensure brevity in your answer.  0.49. What is the ratio of the Payments (BoP, current US$) of Finland in 2005 to that in 2011?
Provide a succinct answer. 0.69. What is the ratio of the Payments (BoP, current US$) of Georgia in 2005 to that in 2011?
Provide a succinct answer. 0.38. What is the ratio of the Payments (BoP, current US$) of Jordan in 2005 to that in 2011?
Your answer should be very brief. 0.55. What is the ratio of the Payments (BoP, current US$) in Tanzania in 2005 to that in 2011?
Keep it short and to the point. 0.37. What is the ratio of the Payments (BoP, current US$) in Finland in 2006 to that in 2007?
Your answer should be compact. 0.82. What is the ratio of the Payments (BoP, current US$) in Georgia in 2006 to that in 2007?
Offer a terse response. 0.72. What is the ratio of the Payments (BoP, current US$) of Jordan in 2006 to that in 2007?
Offer a terse response. 0.84. What is the ratio of the Payments (BoP, current US$) of Tanzania in 2006 to that in 2007?
Keep it short and to the point. 0.78. What is the ratio of the Payments (BoP, current US$) in Finland in 2006 to that in 2008?
Your response must be concise. 0.71. What is the ratio of the Payments (BoP, current US$) in Georgia in 2006 to that in 2008?
Provide a succinct answer. 0.56. What is the ratio of the Payments (BoP, current US$) of Jordan in 2006 to that in 2008?
Keep it short and to the point. 0.7. What is the ratio of the Payments (BoP, current US$) in Tanzania in 2006 to that in 2008?
Offer a terse response. 0.57. What is the ratio of the Payments (BoP, current US$) of Finland in 2006 to that in 2009?
Keep it short and to the point. 1.03. What is the ratio of the Payments (BoP, current US$) of Georgia in 2006 to that in 2009?
Give a very brief answer. 0.79. What is the ratio of the Payments (BoP, current US$) in Jordan in 2006 to that in 2009?
Make the answer very short. 0.81. What is the ratio of the Payments (BoP, current US$) of Tanzania in 2006 to that in 2009?
Give a very brief answer. 0.65. What is the ratio of the Payments (BoP, current US$) in Finland in 2006 to that in 2010?
Give a very brief answer. 0.94. What is the ratio of the Payments (BoP, current US$) in Georgia in 2006 to that in 2010?
Provide a succinct answer. 0.66. What is the ratio of the Payments (BoP, current US$) of Jordan in 2006 to that in 2010?
Provide a short and direct response. 0.71. What is the ratio of the Payments (BoP, current US$) in Tanzania in 2006 to that in 2010?
Provide a succinct answer. 0.55. What is the ratio of the Payments (BoP, current US$) in Finland in 2006 to that in 2011?
Offer a terse response. 0.79. What is the ratio of the Payments (BoP, current US$) of Georgia in 2006 to that in 2011?
Offer a very short reply. 0.5. What is the ratio of the Payments (BoP, current US$) in Jordan in 2006 to that in 2011?
Give a very brief answer. 0.62. What is the ratio of the Payments (BoP, current US$) of Tanzania in 2006 to that in 2011?
Offer a very short reply. 0.42. What is the ratio of the Payments (BoP, current US$) in Finland in 2007 to that in 2008?
Offer a terse response. 0.87. What is the ratio of the Payments (BoP, current US$) in Georgia in 2007 to that in 2008?
Offer a very short reply. 0.78. What is the ratio of the Payments (BoP, current US$) in Jordan in 2007 to that in 2008?
Ensure brevity in your answer.  0.83. What is the ratio of the Payments (BoP, current US$) in Tanzania in 2007 to that in 2008?
Make the answer very short. 0.73. What is the ratio of the Payments (BoP, current US$) in Finland in 2007 to that in 2009?
Your response must be concise. 1.26. What is the ratio of the Payments (BoP, current US$) in Georgia in 2007 to that in 2009?
Provide a short and direct response. 1.09. What is the ratio of the Payments (BoP, current US$) of Jordan in 2007 to that in 2009?
Your answer should be compact. 0.96. What is the ratio of the Payments (BoP, current US$) in Tanzania in 2007 to that in 2009?
Give a very brief answer. 0.83. What is the ratio of the Payments (BoP, current US$) in Finland in 2007 to that in 2010?
Ensure brevity in your answer.  1.15. What is the ratio of the Payments (BoP, current US$) of Georgia in 2007 to that in 2010?
Give a very brief answer. 0.92. What is the ratio of the Payments (BoP, current US$) in Jordan in 2007 to that in 2010?
Provide a succinct answer. 0.85. What is the ratio of the Payments (BoP, current US$) in Tanzania in 2007 to that in 2010?
Your response must be concise. 0.7. What is the ratio of the Payments (BoP, current US$) in Finland in 2007 to that in 2011?
Ensure brevity in your answer.  0.96. What is the ratio of the Payments (BoP, current US$) of Georgia in 2007 to that in 2011?
Make the answer very short. 0.69. What is the ratio of the Payments (BoP, current US$) of Jordan in 2007 to that in 2011?
Make the answer very short. 0.74. What is the ratio of the Payments (BoP, current US$) in Tanzania in 2007 to that in 2011?
Provide a succinct answer. 0.53. What is the ratio of the Payments (BoP, current US$) of Finland in 2008 to that in 2009?
Ensure brevity in your answer.  1.45. What is the ratio of the Payments (BoP, current US$) of Georgia in 2008 to that in 2009?
Your answer should be very brief. 1.4. What is the ratio of the Payments (BoP, current US$) of Jordan in 2008 to that in 2009?
Ensure brevity in your answer.  1.17. What is the ratio of the Payments (BoP, current US$) in Tanzania in 2008 to that in 2009?
Your answer should be very brief. 1.14. What is the ratio of the Payments (BoP, current US$) in Finland in 2008 to that in 2010?
Provide a succinct answer. 1.32. What is the ratio of the Payments (BoP, current US$) of Georgia in 2008 to that in 2010?
Provide a short and direct response. 1.18. What is the ratio of the Payments (BoP, current US$) of Jordan in 2008 to that in 2010?
Offer a terse response. 1.03. What is the ratio of the Payments (BoP, current US$) in Tanzania in 2008 to that in 2010?
Your answer should be very brief. 0.95. What is the ratio of the Payments (BoP, current US$) of Finland in 2008 to that in 2011?
Provide a succinct answer. 1.11. What is the ratio of the Payments (BoP, current US$) of Georgia in 2008 to that in 2011?
Ensure brevity in your answer.  0.89. What is the ratio of the Payments (BoP, current US$) in Jordan in 2008 to that in 2011?
Provide a succinct answer. 0.89. What is the ratio of the Payments (BoP, current US$) in Tanzania in 2008 to that in 2011?
Your response must be concise. 0.73. What is the ratio of the Payments (BoP, current US$) of Finland in 2009 to that in 2010?
Offer a very short reply. 0.91. What is the ratio of the Payments (BoP, current US$) of Georgia in 2009 to that in 2010?
Your answer should be very brief. 0.84. What is the ratio of the Payments (BoP, current US$) in Jordan in 2009 to that in 2010?
Offer a terse response. 0.88. What is the ratio of the Payments (BoP, current US$) of Tanzania in 2009 to that in 2010?
Offer a terse response. 0.84. What is the ratio of the Payments (BoP, current US$) in Finland in 2009 to that in 2011?
Keep it short and to the point. 0.77. What is the ratio of the Payments (BoP, current US$) of Georgia in 2009 to that in 2011?
Your answer should be very brief. 0.63. What is the ratio of the Payments (BoP, current US$) in Jordan in 2009 to that in 2011?
Keep it short and to the point. 0.77. What is the ratio of the Payments (BoP, current US$) of Tanzania in 2009 to that in 2011?
Your answer should be compact. 0.64. What is the ratio of the Payments (BoP, current US$) in Finland in 2010 to that in 2011?
Your answer should be very brief. 0.84. What is the ratio of the Payments (BoP, current US$) in Georgia in 2010 to that in 2011?
Your answer should be compact. 0.75. What is the ratio of the Payments (BoP, current US$) in Jordan in 2010 to that in 2011?
Keep it short and to the point. 0.87. What is the ratio of the Payments (BoP, current US$) in Tanzania in 2010 to that in 2011?
Offer a terse response. 0.76. What is the difference between the highest and the second highest Payments (BoP, current US$) of Finland?
Your response must be concise. 1.44e+1. What is the difference between the highest and the second highest Payments (BoP, current US$) in Georgia?
Offer a terse response. 1.05e+09. What is the difference between the highest and the second highest Payments (BoP, current US$) in Jordan?
Offer a terse response. 2.41e+09. What is the difference between the highest and the second highest Payments (BoP, current US$) of Tanzania?
Your response must be concise. 2.94e+09. What is the difference between the highest and the lowest Payments (BoP, current US$) in Finland?
Provide a short and direct response. 5.41e+1. What is the difference between the highest and the lowest Payments (BoP, current US$) in Georgia?
Ensure brevity in your answer.  5.70e+09. What is the difference between the highest and the lowest Payments (BoP, current US$) in Jordan?
Keep it short and to the point. 9.96e+09. What is the difference between the highest and the lowest Payments (BoP, current US$) in Tanzania?
Your answer should be compact. 7.84e+09. 